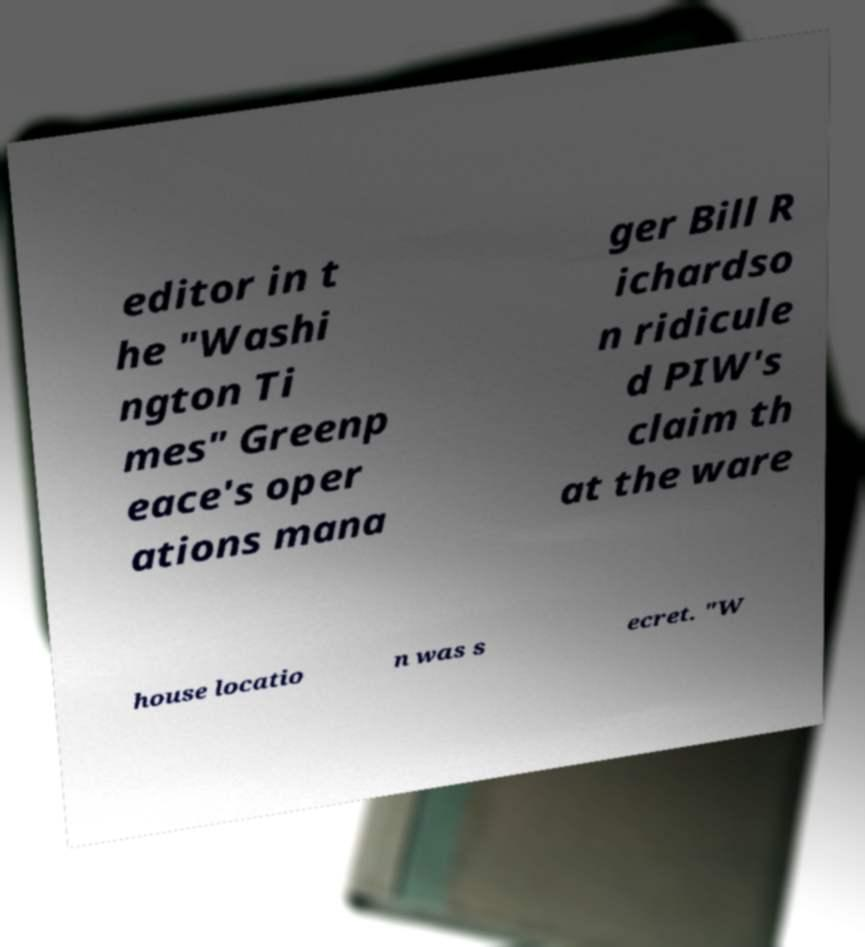Can you accurately transcribe the text from the provided image for me? editor in t he "Washi ngton Ti mes" Greenp eace's oper ations mana ger Bill R ichardso n ridicule d PIW's claim th at the ware house locatio n was s ecret. "W 